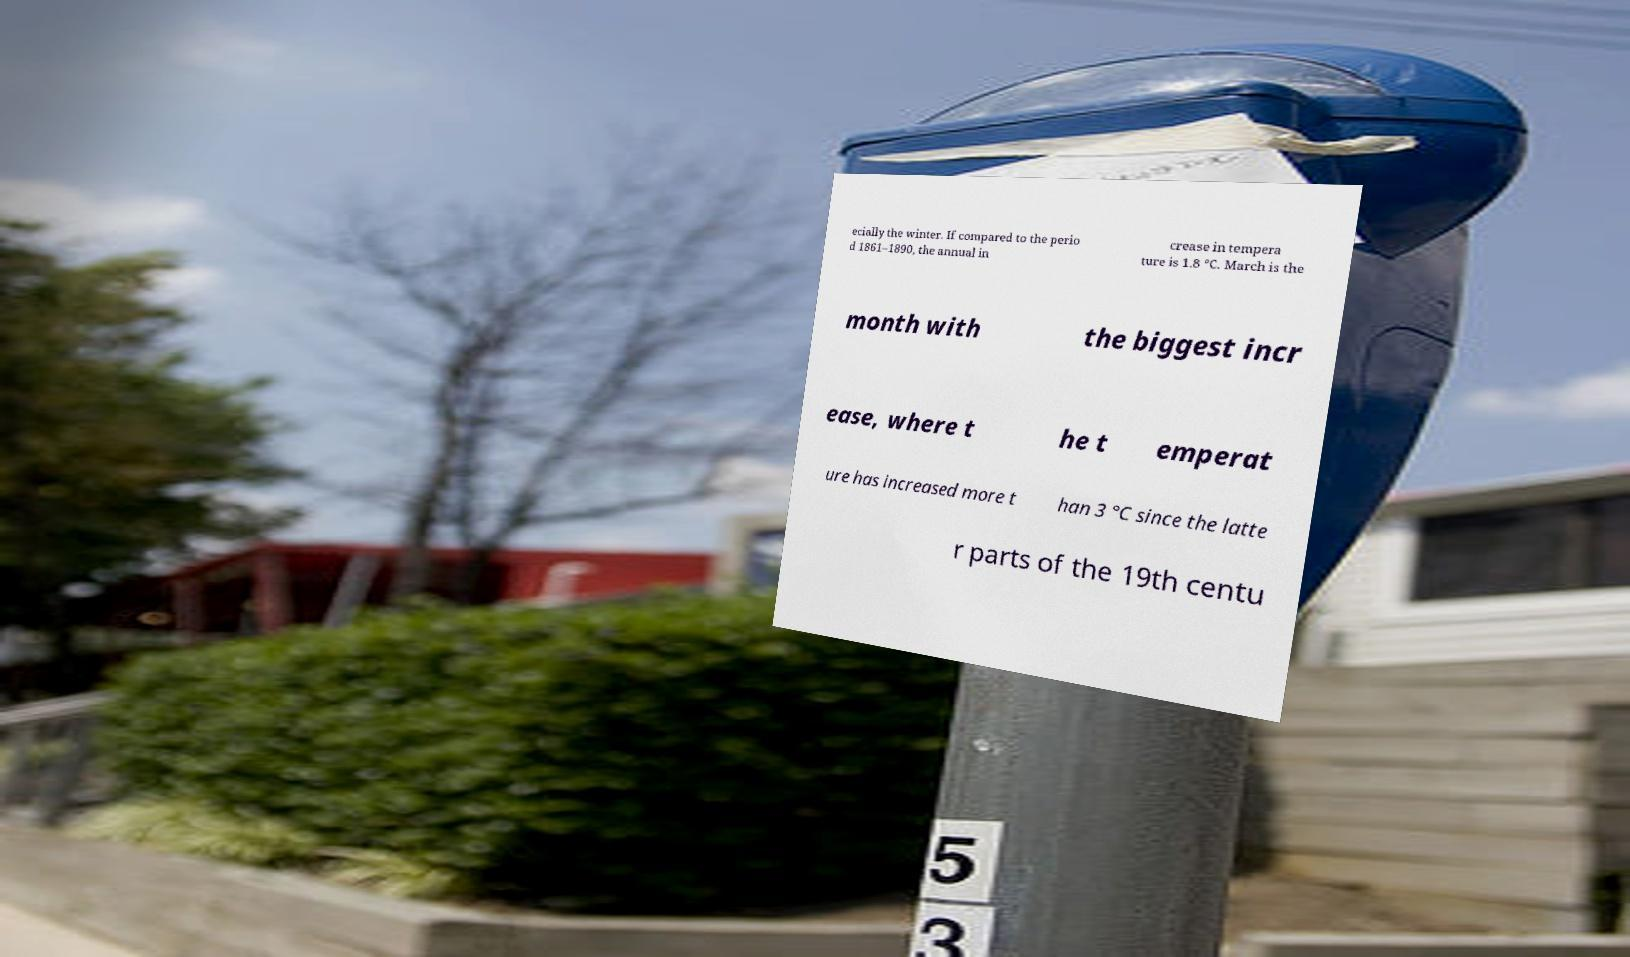Can you accurately transcribe the text from the provided image for me? ecially the winter. If compared to the perio d 1861–1890, the annual in crease in tempera ture is 1.8 °C. March is the month with the biggest incr ease, where t he t emperat ure has increased more t han 3 °C since the latte r parts of the 19th centu 